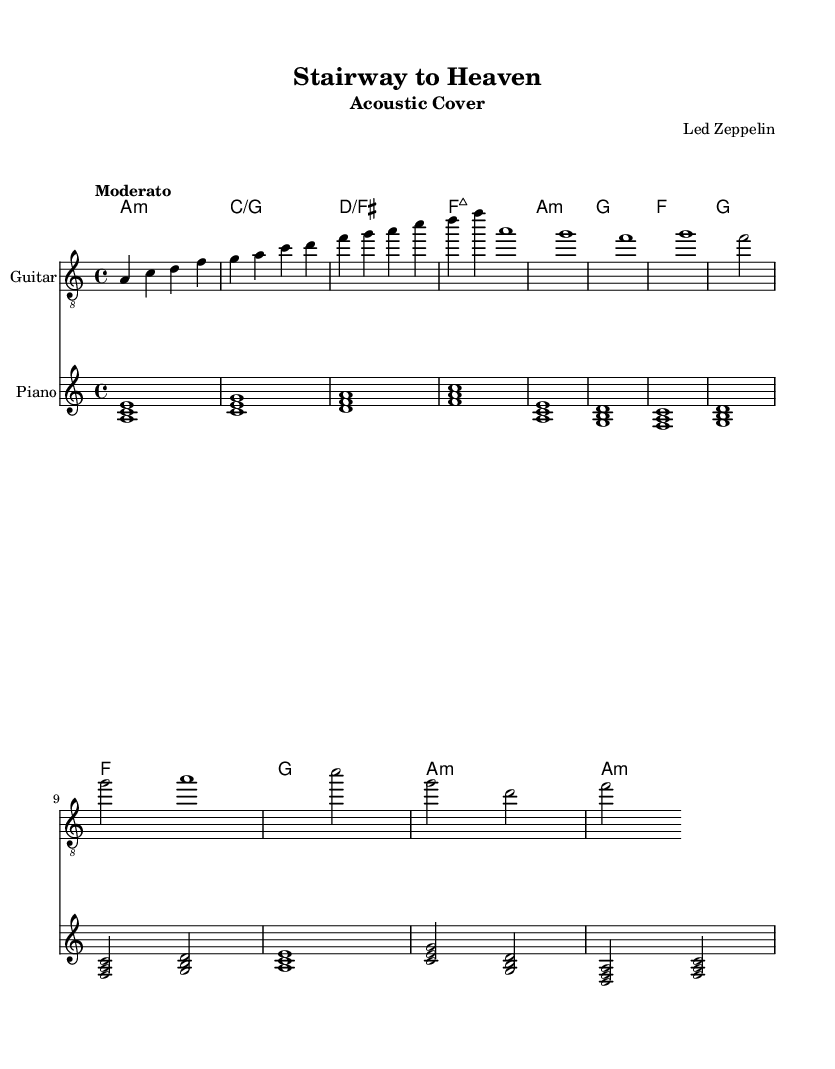What is the key signature of this music? The key signature has two sharps (F# and C#) indicating it is in A minor, which is the relative minor of C major and sometimes marked with no sharps or flats when depicted in this way.
Answer: A minor What is the time signature of this music? The time signature is at the beginning of the sheet music, represented as 4/4, meaning there are four beats in each measure and a quarter note gets one beat.
Answer: 4/4 What is the tempo marking of this piece? The tempo marking is written at the beginning of the music as "Moderato," suggesting a moderate speed, typically around 108-120 beats per minute.
Answer: Moderato How many sections are there in this arrangement? The arrangement consists of an intro, verse 1, and a bridge, which can be counted based on the distinct musical sections indicated in the music.
Answer: 3 What is the first chord in the music? The first chord appears at the beginning of the score as "A minor," which is noted in the chord names section.
Answer: A minor What instruments are used in this arrangement? The instruments are specified in the score, where you see a "Guitar" staff and a "Piano" staff, indicating these are the two instruments used.
Answer: Guitar and Piano What type of musical composition is this? This piece is classified as a famous rock song that has been arranged for acoustic instruments, particularly known for its lasting popularity and cultural impact.
Answer: Acoustic cover 